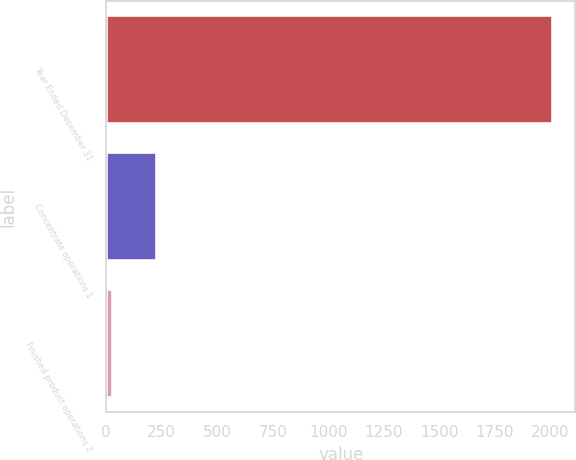Convert chart. <chart><loc_0><loc_0><loc_500><loc_500><bar_chart><fcel>Year Ended December 31<fcel>Concentrate operations 1<fcel>Finished product operations 2<nl><fcel>2012<fcel>228.2<fcel>30<nl></chart> 